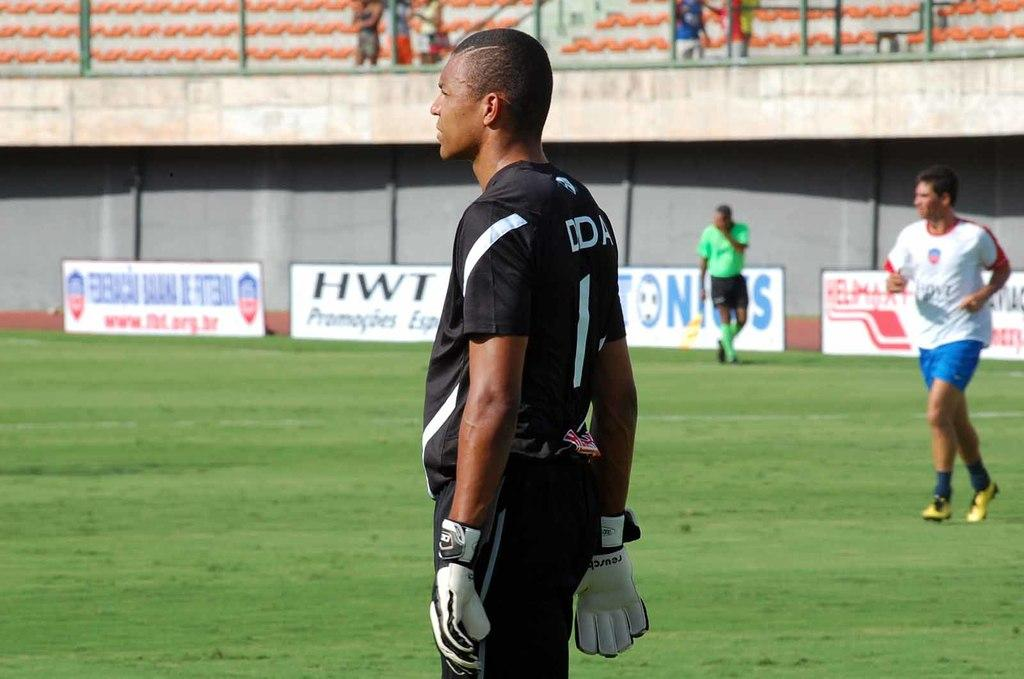<image>
Offer a succinct explanation of the picture presented. Athlete on the field with the words HWT in the back. 